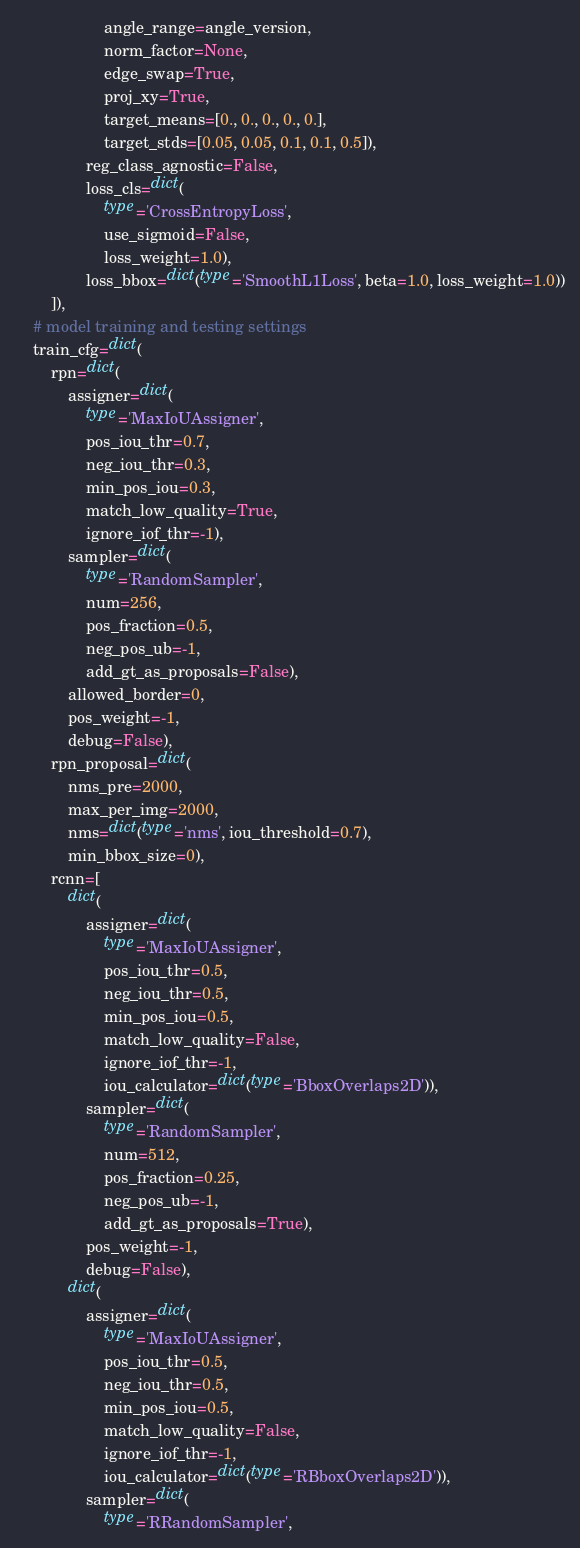Convert code to text. <code><loc_0><loc_0><loc_500><loc_500><_Python_>                    angle_range=angle_version,
                    norm_factor=None,
                    edge_swap=True,
                    proj_xy=True,
                    target_means=[0., 0., 0., 0., 0.],
                    target_stds=[0.05, 0.05, 0.1, 0.1, 0.5]),
                reg_class_agnostic=False,
                loss_cls=dict(
                    type='CrossEntropyLoss',
                    use_sigmoid=False,
                    loss_weight=1.0),
                loss_bbox=dict(type='SmoothL1Loss', beta=1.0, loss_weight=1.0))
        ]),
    # model training and testing settings
    train_cfg=dict(
        rpn=dict(
            assigner=dict(
                type='MaxIoUAssigner',
                pos_iou_thr=0.7,
                neg_iou_thr=0.3,
                min_pos_iou=0.3,
                match_low_quality=True,
                ignore_iof_thr=-1),
            sampler=dict(
                type='RandomSampler',
                num=256,
                pos_fraction=0.5,
                neg_pos_ub=-1,
                add_gt_as_proposals=False),
            allowed_border=0,
            pos_weight=-1,
            debug=False),
        rpn_proposal=dict(
            nms_pre=2000,
            max_per_img=2000,
            nms=dict(type='nms', iou_threshold=0.7),
            min_bbox_size=0),
        rcnn=[
            dict(
                assigner=dict(
                    type='MaxIoUAssigner',
                    pos_iou_thr=0.5,
                    neg_iou_thr=0.5,
                    min_pos_iou=0.5,
                    match_low_quality=False,
                    ignore_iof_thr=-1,
                    iou_calculator=dict(type='BboxOverlaps2D')),
                sampler=dict(
                    type='RandomSampler',
                    num=512,
                    pos_fraction=0.25,
                    neg_pos_ub=-1,
                    add_gt_as_proposals=True),
                pos_weight=-1,
                debug=False),
            dict(
                assigner=dict(
                    type='MaxIoUAssigner',
                    pos_iou_thr=0.5,
                    neg_iou_thr=0.5,
                    min_pos_iou=0.5,
                    match_low_quality=False,
                    ignore_iof_thr=-1,
                    iou_calculator=dict(type='RBboxOverlaps2D')),
                sampler=dict(
                    type='RRandomSampler',</code> 